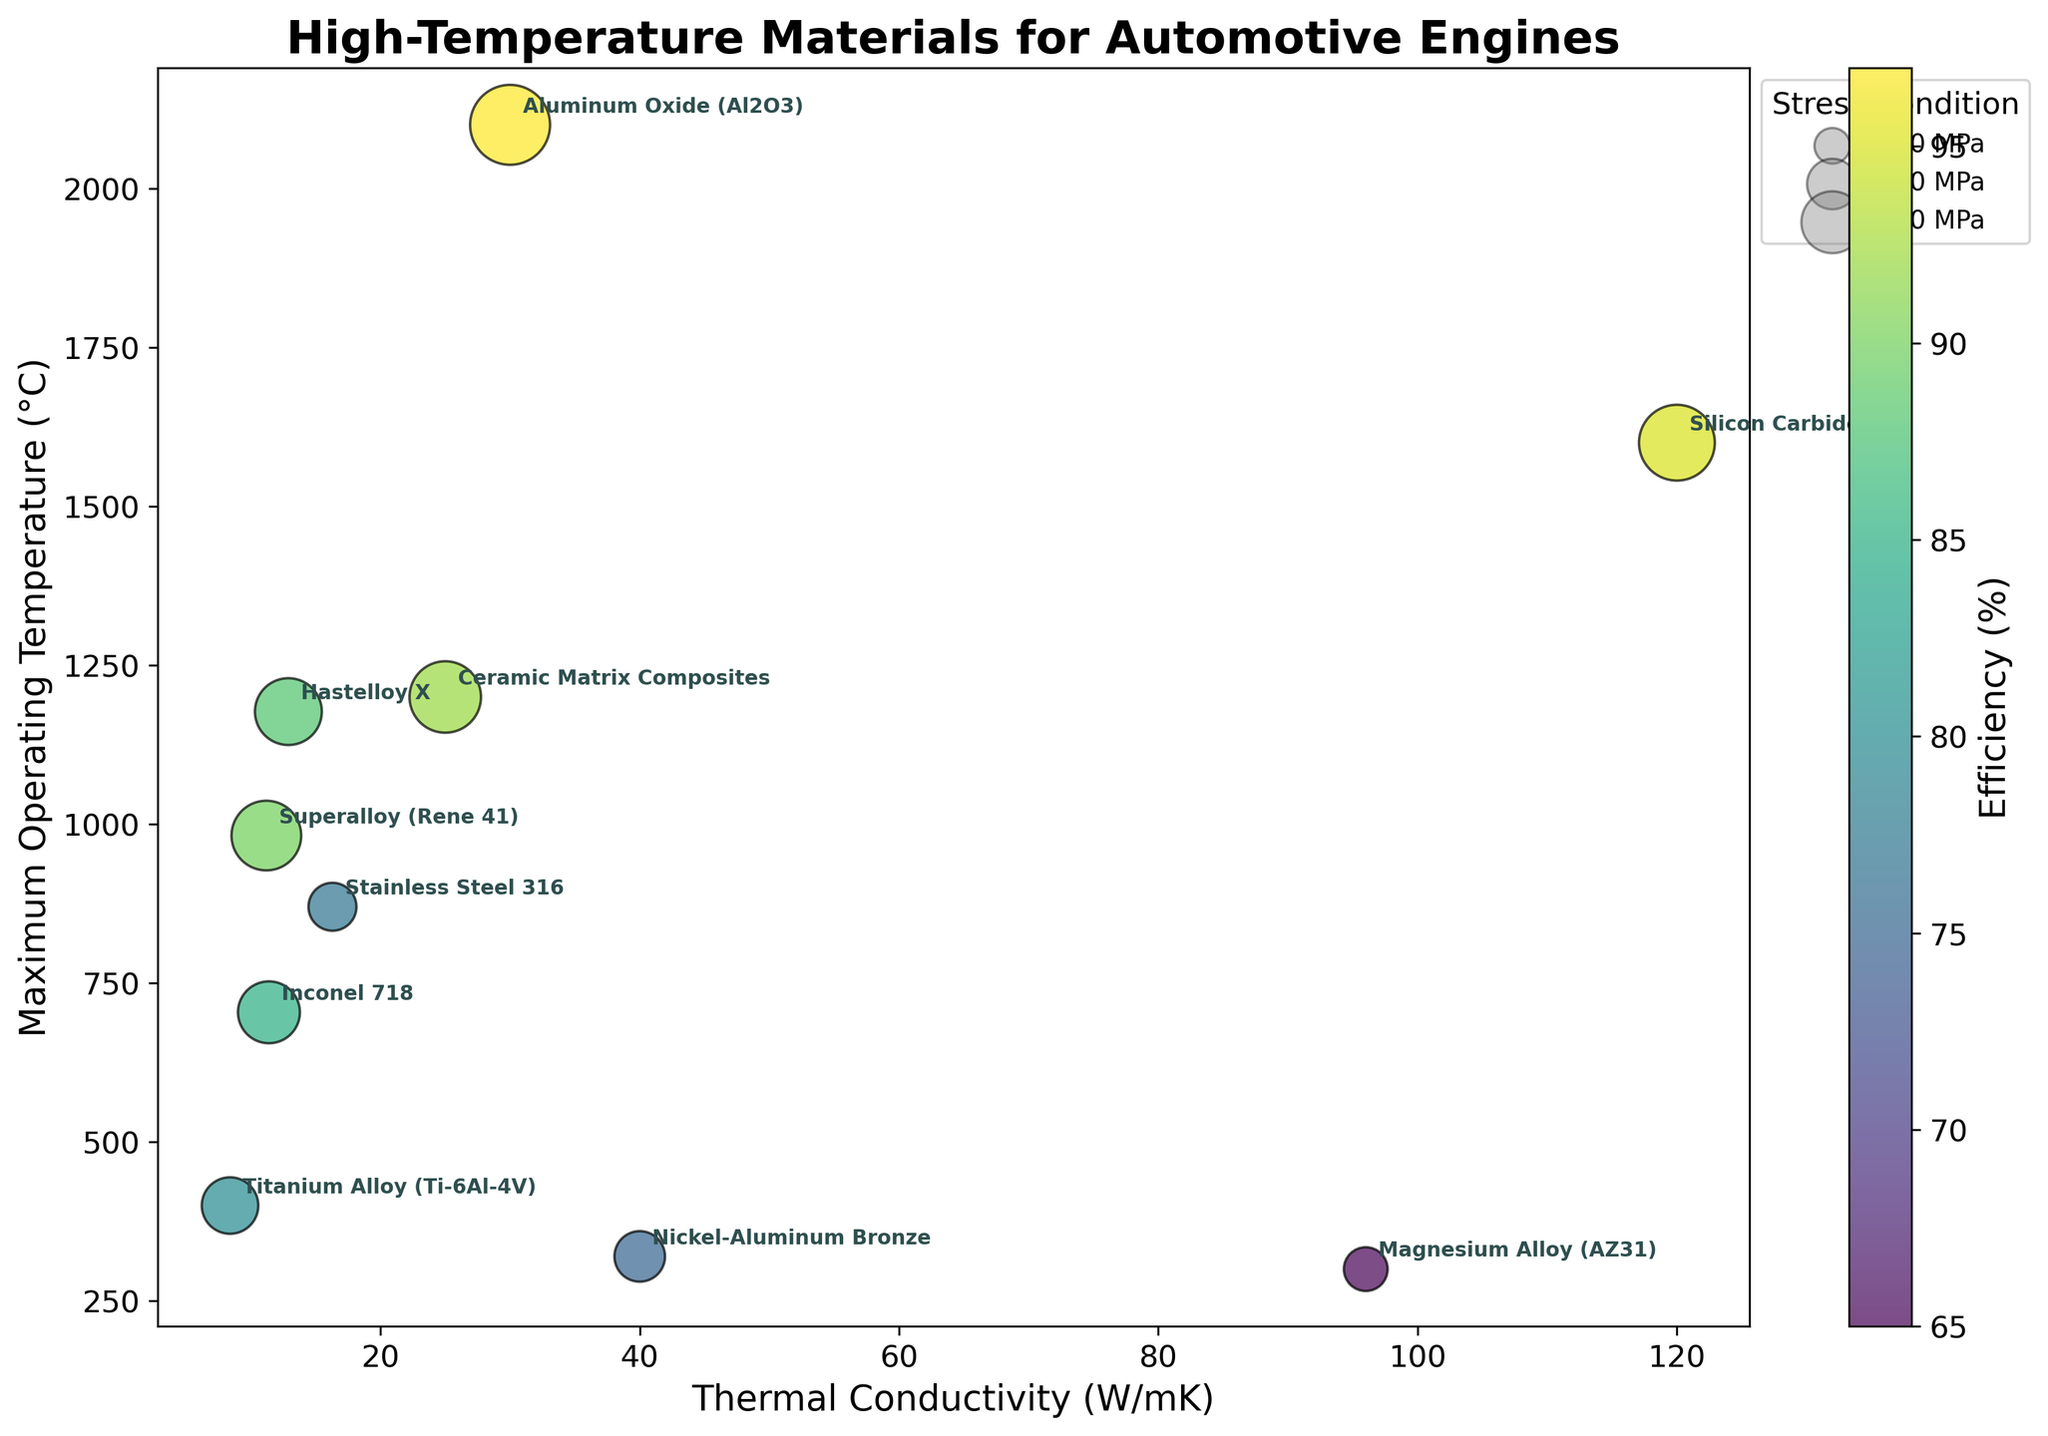What is the title of the figure? The title is displayed at the top of the figure.
Answer: High-Temperature Materials for Automotive Engines What does the x-axis represent? The x-axis is labeled and represents thermal conductivity in W/mK.
Answer: Thermal Conductivity (W/mK) Which material has the highest efficiency percentage? The color scale indicates efficiency, with the brightest color representing the highest efficiency. By looking closely, Aluminum Oxide (Al2O3) has the highest efficiency at 97%.
Answer: Aluminum Oxide (Al2O3) How many data points are there in the figure? Counting the number of annotated points or bubbles in the figure will give the total data points.
Answer: 10 Which material can withstand the highest stress condition? The largest bubble size corresponds to the highest stress condition, which for Aluminum Oxide (Al2O3) is 500 MPa.
Answer: Aluminum Oxide (Al2O3) Compare the efficiency percentages of Inconel 718 and Hastelloy X. Find the colors on the bubbles that represent Inconel 718 and Hastelloy X. Inconel 718 has an efficiency of 85%, and Hastelloy X has 88%.
Answer: Hastelloy X is more efficient What is the compositional question for finding the average thermal conductivity of the materials? Sum the thermal conductivities and divide by the number of materials: (11.4 + 25 + 8.4 + 12.9 + 40 + 16.3 + 120 + 11.2 + 30 + 96)/10 = 37.42 W/mK
Answer: 37.42 W/mK What is the maximum operating temperature for Silicon Carbide? Locate the y-coordinate of the bubble labeled Silicon Carbide, which is 1600°C.
Answer: 1600°C Which material has the lowest thermal conductivity? The x-axis represents thermal conductivity, and the material closest to the origin has the lowest, which is Titanium Alloy (Ti-6Al-4V) with 8.4 W/mK.
Answer: Titanium Alloy (Ti-6Al-4V) Does Aluminum Oxide or Magnesium Alloy have a higher maximum operating temperature? By comparing the y-coordinates of Aluminum Oxide and Magnesium Alloy bubbles, Aluminum Oxide has a higher maximum operating temperature (2100°C).
Answer: Aluminum Oxide What is the relationship between thermal conductivity and efficiency among the materials? Observe the color gradient along the x-axis. Higher thermal conductivity does not directly correlate with higher efficiency since various efficiency percentages are scattered across different thermal conductivities.
Answer: No direct correlation 